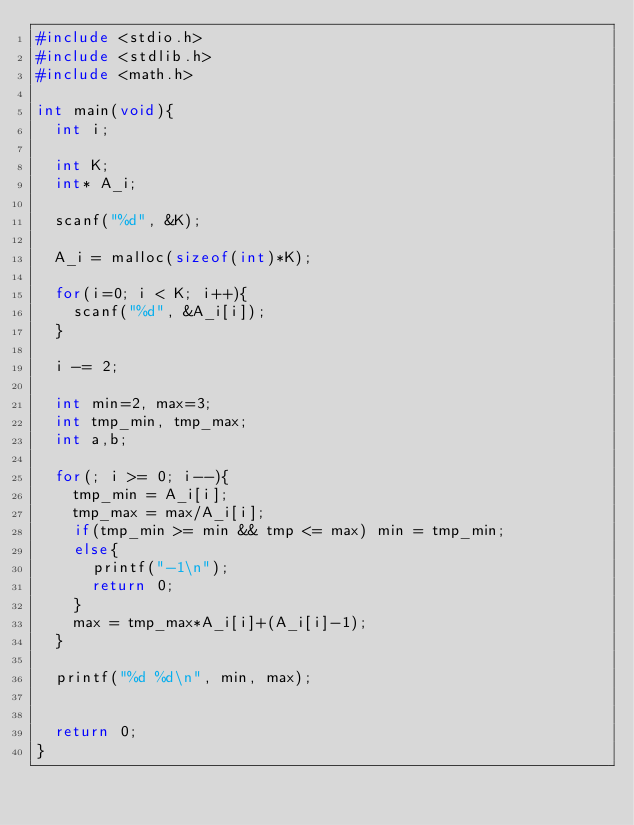<code> <loc_0><loc_0><loc_500><loc_500><_C_>#include <stdio.h>
#include <stdlib.h>
#include <math.h>

int main(void){
	int i;

	int K;
	int* A_i;

	scanf("%d", &K);

	A_i = malloc(sizeof(int)*K);

	for(i=0; i < K; i++){
		scanf("%d", &A_i[i]);
	}

	i -= 2;

	int min=2, max=3;
	int tmp_min, tmp_max;
	int a,b;

	for(; i >= 0; i--){
		tmp_min = A_i[i];
		tmp_max = max/A_i[i];
		if(tmp_min >= min && tmp <= max) min = tmp_min;
		else{
			printf("-1\n");
			return 0;
		}
		max = tmp_max*A_i[i]+(A_i[i]-1);
	}

	printf("%d %d\n", min, max);


	return 0;
}</code> 